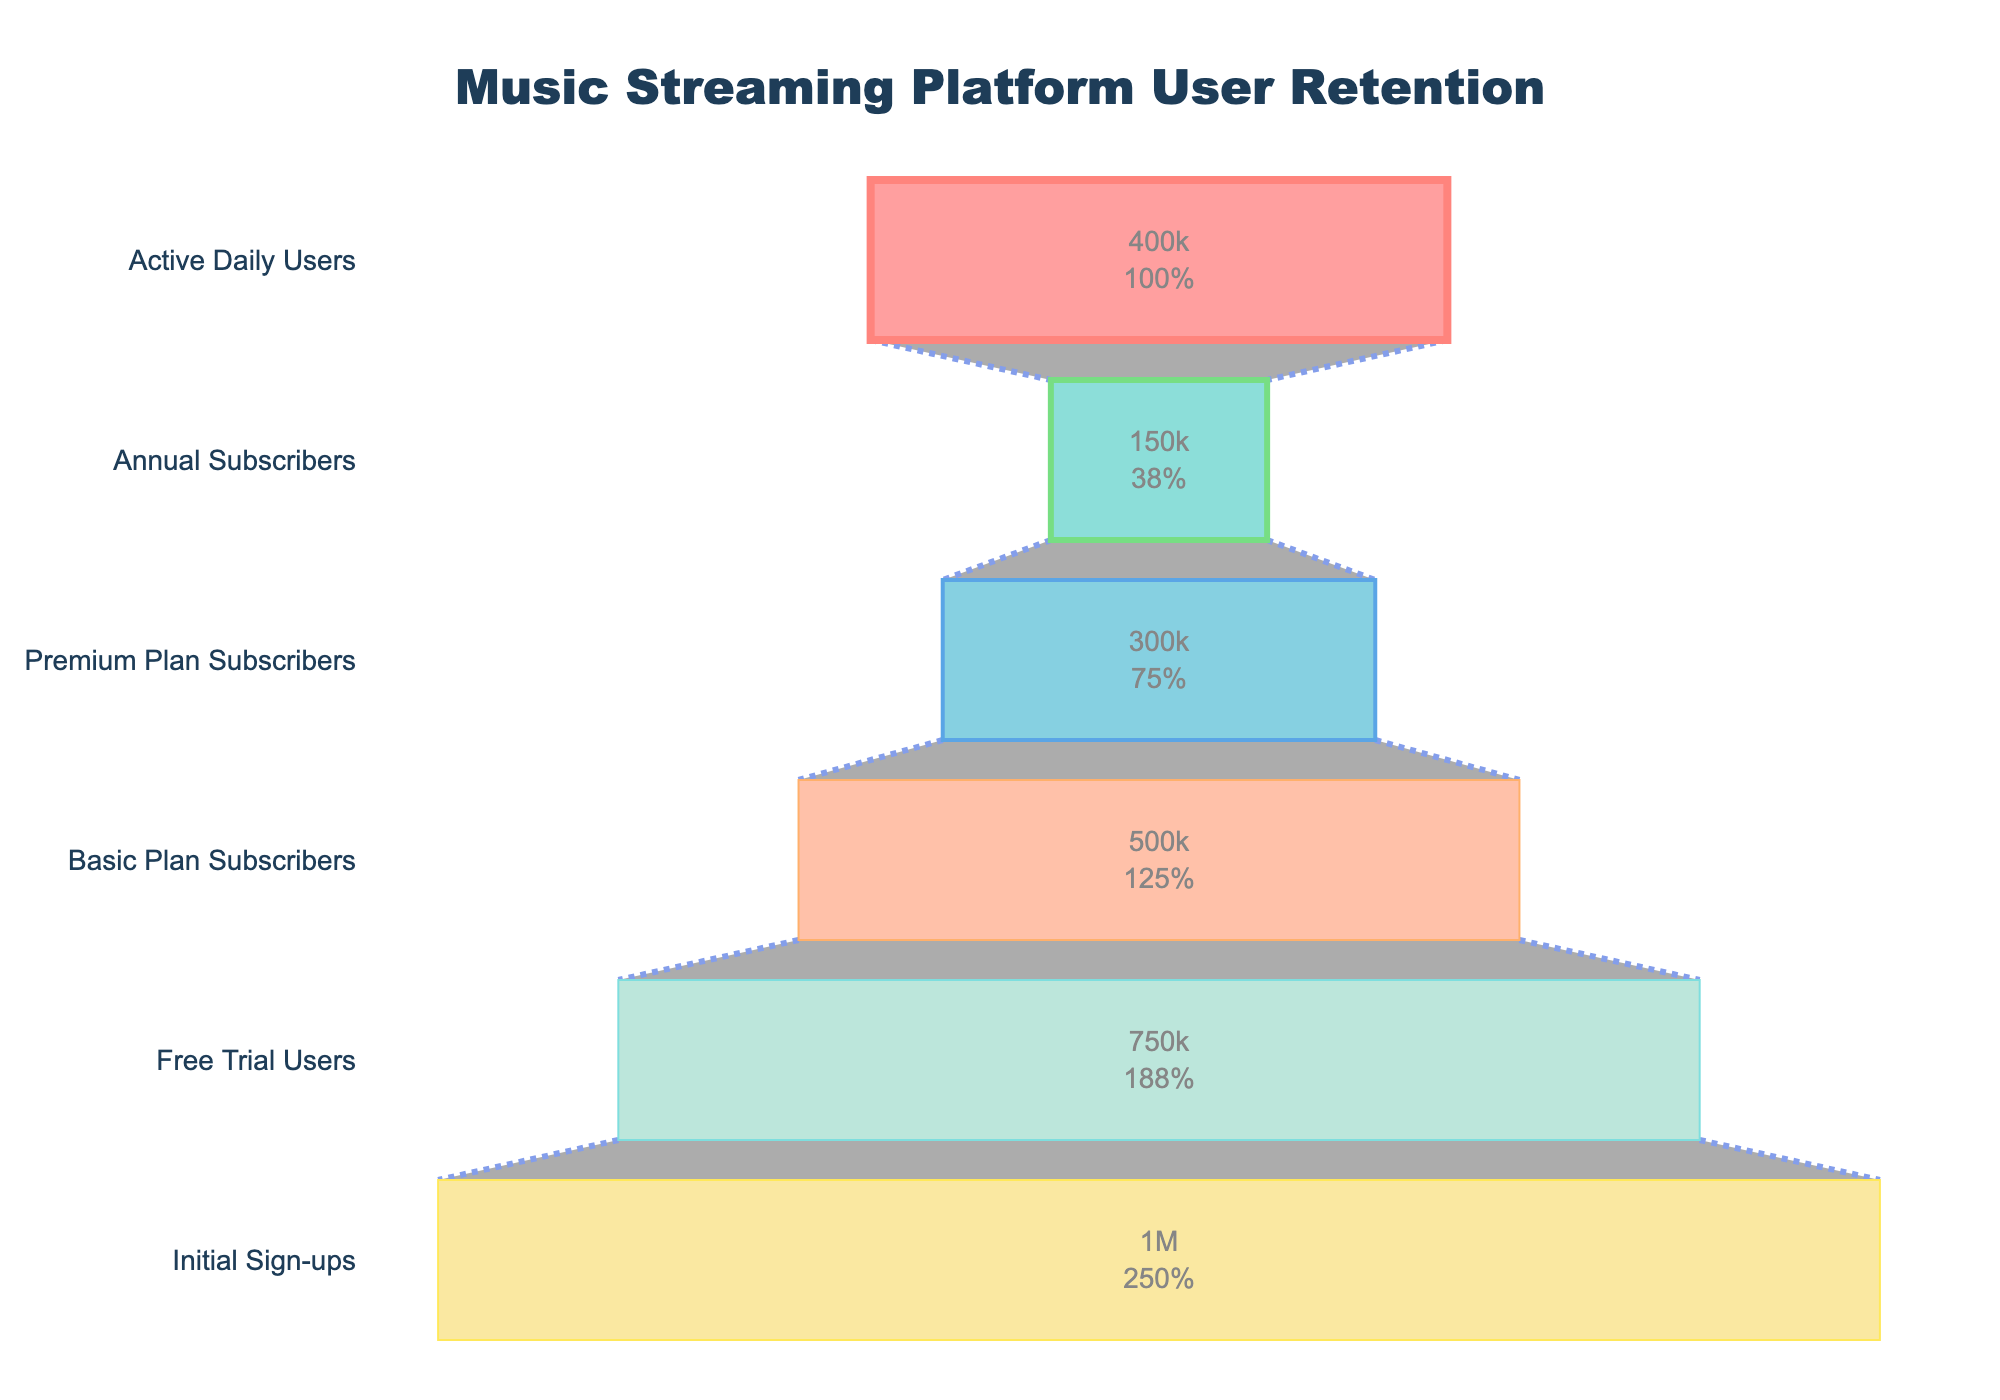What is the total number of users who initially signed up? The figure shows that the initial sign-ups are labeled at 1,000,000 users.
Answer: 1,000,000 How many users are Premium Plan Subscribers? The chart indicates that there are 300,000 users who are Premium Plan Subscribers.
Answer: 300,000 By how much did the number of users decrease from Free Trial Users to Basic Plan Subscribers? Subtract the number of Basic Plan Subscribers (500,000) from Free Trial Users (750,000). This results in a decrease of 250,000 users.
Answer: 250,000 What percentage of the initial sign-ups are Annual Subscribers? Annual Subscribers are 150,000 out of 1,000,000 initial sign-ups. This is calculated as (150,000 / 1,000,000) * 100%, equating to 15%.
Answer: 15% Are there more Active Daily Users or Premium Plan Subscribers? The chart displays 400,000 Active Daily Users compared to 300,000 Premium Plan Subscribers. Thus, there are more Active Daily Users.
Answer: Active Daily Users What is the difference between Active Daily Users and Annual Subscribers? Subtract the number of Annual Subscribers (150,000) from Active Daily Users (400,000), which gives a difference of 250,000.
Answer: 250,000 Which stage has the lowest number of users? The chart indicates that the stage with the lowest number of users is the Annual Subscribers stage, with 150,000 users.
Answer: Annual Subscribers What is the cumulative number of users from the stages of Premium Plan Subscribers and Annual Subscribers? Sum the numbers: 300,000 (Premium Plan Subscribers) + 150,000 (Annual Subscribers) = 450,000 users.
Answer: 450,000 